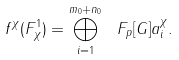<formula> <loc_0><loc_0><loc_500><loc_500>f ^ { \chi } ( F ^ { 1 } _ { \chi } ) = \bigoplus _ { i = 1 } ^ { m _ { 0 } + n _ { 0 } } \ F _ { p } [ G ] a _ { i } ^ { \chi } .</formula> 